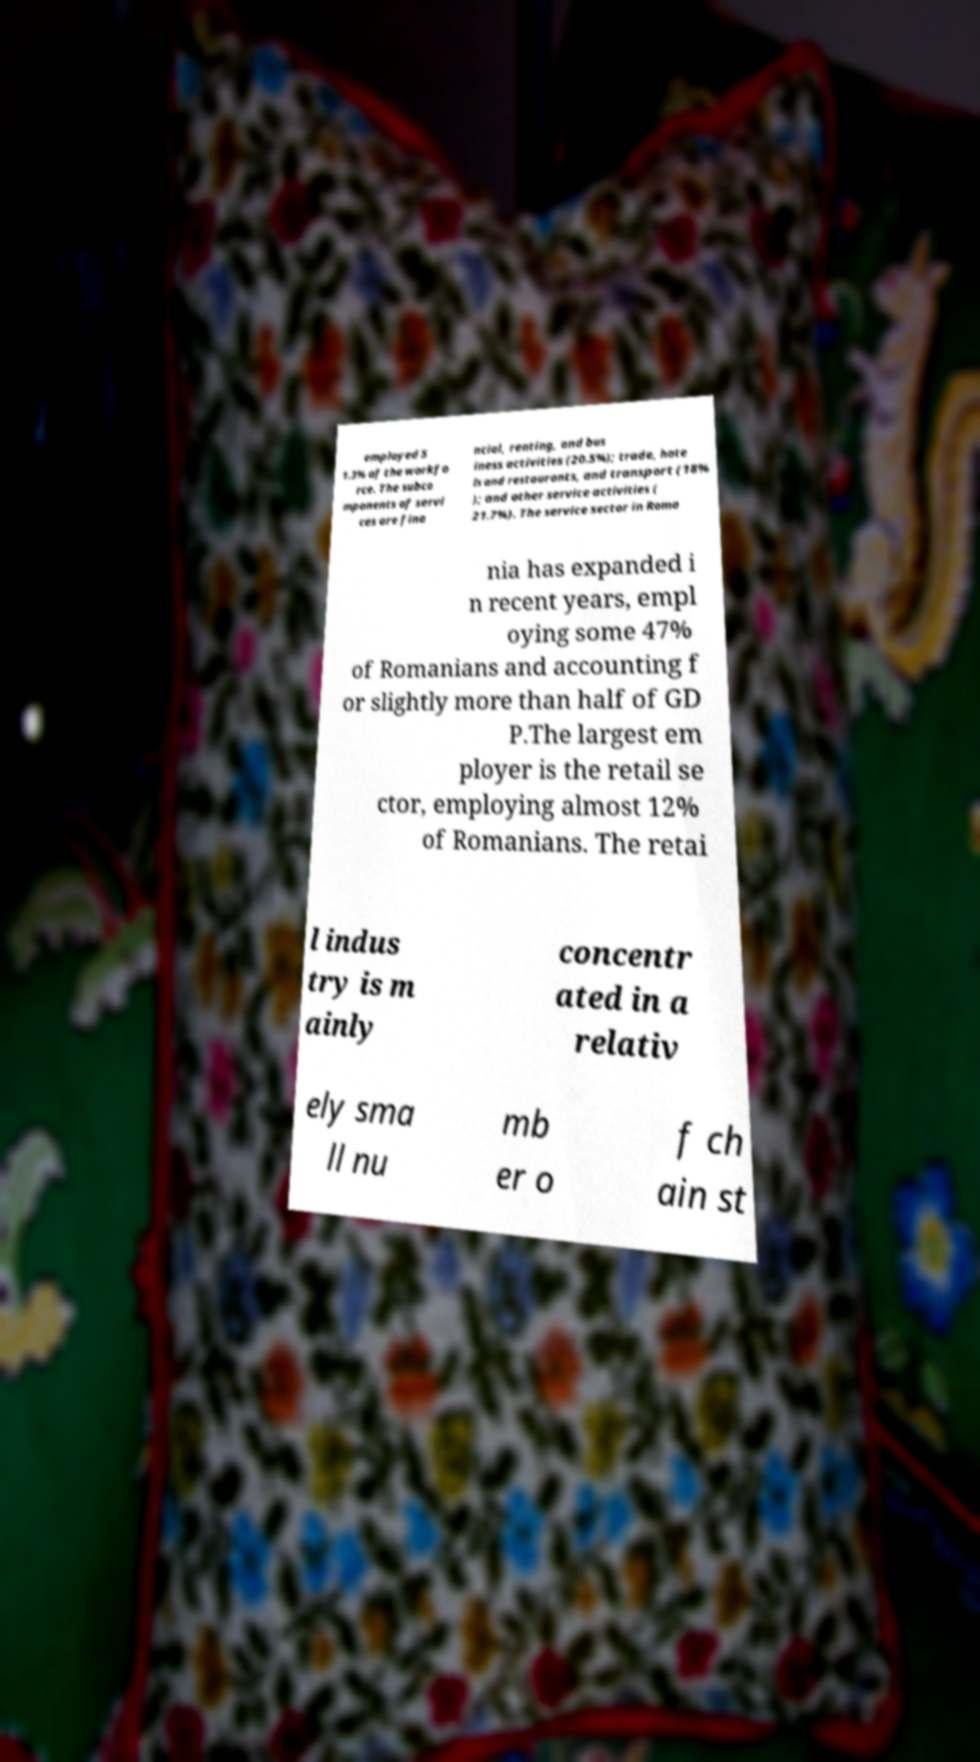For documentation purposes, I need the text within this image transcribed. Could you provide that? employed 5 1.3% of the workfo rce. The subco mponents of servi ces are fina ncial, renting, and bus iness activities (20.5%); trade, hote ls and restaurants, and transport (18% ); and other service activities ( 21.7%). The service sector in Roma nia has expanded i n recent years, empl oying some 47% of Romanians and accounting f or slightly more than half of GD P.The largest em ployer is the retail se ctor, employing almost 12% of Romanians. The retai l indus try is m ainly concentr ated in a relativ ely sma ll nu mb er o f ch ain st 